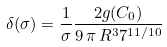<formula> <loc_0><loc_0><loc_500><loc_500>\delta ( \sigma ) = \frac { 1 } { \sigma } \frac { 2 g ( C _ { 0 } ) } { 9 \, \pi \, R ^ { 3 } 7 ^ { 1 1 / 1 0 } }</formula> 